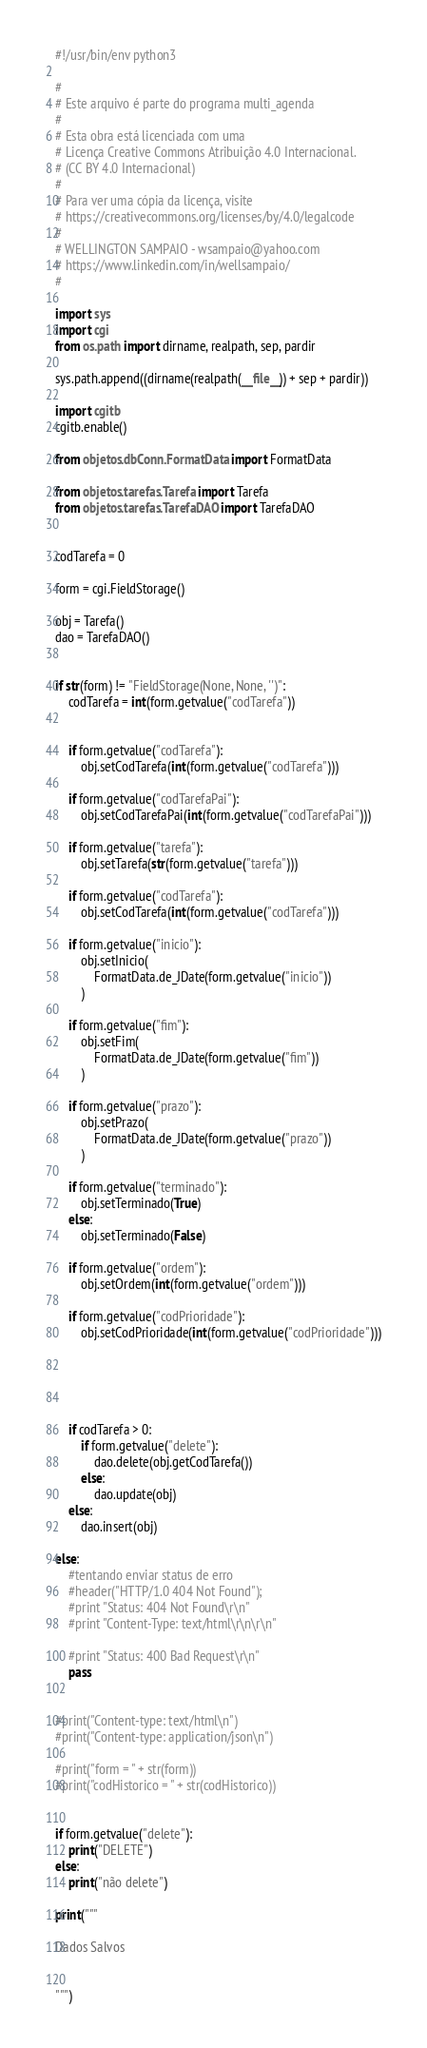<code> <loc_0><loc_0><loc_500><loc_500><_Python_>#!/usr/bin/env python3

#
# Este arquivo é parte do programa multi_agenda
#
# Esta obra está licenciada com uma 
# Licença Creative Commons Atribuição 4.0 Internacional.
# (CC BY 4.0 Internacional)
#  
# Para ver uma cópia da licença, visite
# https://creativecommons.org/licenses/by/4.0/legalcode
# 
# WELLINGTON SAMPAIO - wsampaio@yahoo.com
# https://www.linkedin.com/in/wellsampaio/
#

import sys
import cgi
from os.path import dirname, realpath, sep, pardir

sys.path.append((dirname(realpath(__file__)) + sep + pardir))

import cgitb
cgitb.enable()

from objetos.dbConn.FormatData import FormatData

from objetos.tarefas.Tarefa import Tarefa
from objetos.tarefas.TarefaDAO import TarefaDAO


codTarefa = 0

form = cgi.FieldStorage()

obj = Tarefa()
dao = TarefaDAO()


if str(form) != "FieldStorage(None, None, '')":
	codTarefa = int(form.getvalue("codTarefa"))


	if form.getvalue("codTarefa"):
		obj.setCodTarefa(int(form.getvalue("codTarefa")))

	if form.getvalue("codTarefaPai"):
		obj.setCodTarefaPai(int(form.getvalue("codTarefaPai")))

	if form.getvalue("tarefa"):
		obj.setTarefa(str(form.getvalue("tarefa")))

	if form.getvalue("codTarefa"):
		obj.setCodTarefa(int(form.getvalue("codTarefa")))

	if form.getvalue("inicio"):
		obj.setInicio(
			FormatData.de_JDate(form.getvalue("inicio"))
		)

	if form.getvalue("fim"):
		obj.setFim(
			FormatData.de_JDate(form.getvalue("fim"))
		)

	if form.getvalue("prazo"):
		obj.setPrazo(
			FormatData.de_JDate(form.getvalue("prazo"))
		)

	if form.getvalue("terminado"):
		obj.setTerminado(True)
	else:
		obj.setTerminado(False)

	if form.getvalue("ordem"):
		obj.setOrdem(int(form.getvalue("ordem")))

	if form.getvalue("codPrioridade"):
		obj.setCodPrioridade(int(form.getvalue("codPrioridade")))





	if codTarefa > 0:
		if form.getvalue("delete"):
			dao.delete(obj.getCodTarefa())
		else:
			dao.update(obj)
	else:
		dao.insert(obj)

else:
	#tentando enviar status de erro
	#header("HTTP/1.0 404 Not Found");
	#print "Status: 404 Not Found\r\n"
	#print "Content-Type: text/html\r\n\r\n"
	
	#print "Status: 400 Bad Request\r\n"
	pass


#print("Content-type: text/html\n")
#print("Content-type: application/json\n")

#print("form = " + str(form))
#print("codHistorico = " + str(codHistorico))


if form.getvalue("delete"):
	print("DELETE")
else:
	print("não delete")

print("""

Dados Salvos


""")




</code> 